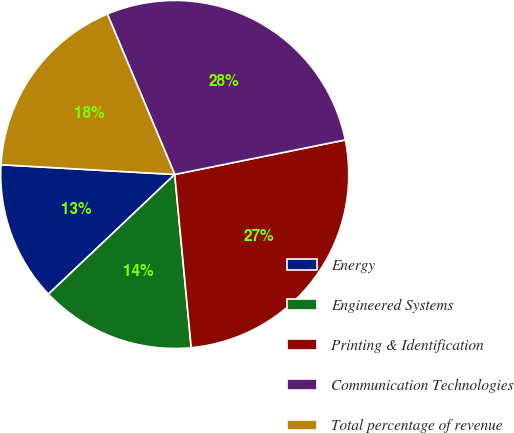Convert chart. <chart><loc_0><loc_0><loc_500><loc_500><pie_chart><fcel>Energy<fcel>Engineered Systems<fcel>Printing & Identification<fcel>Communication Technologies<fcel>Total percentage of revenue<nl><fcel>12.96%<fcel>14.44%<fcel>26.67%<fcel>28.15%<fcel>17.78%<nl></chart> 